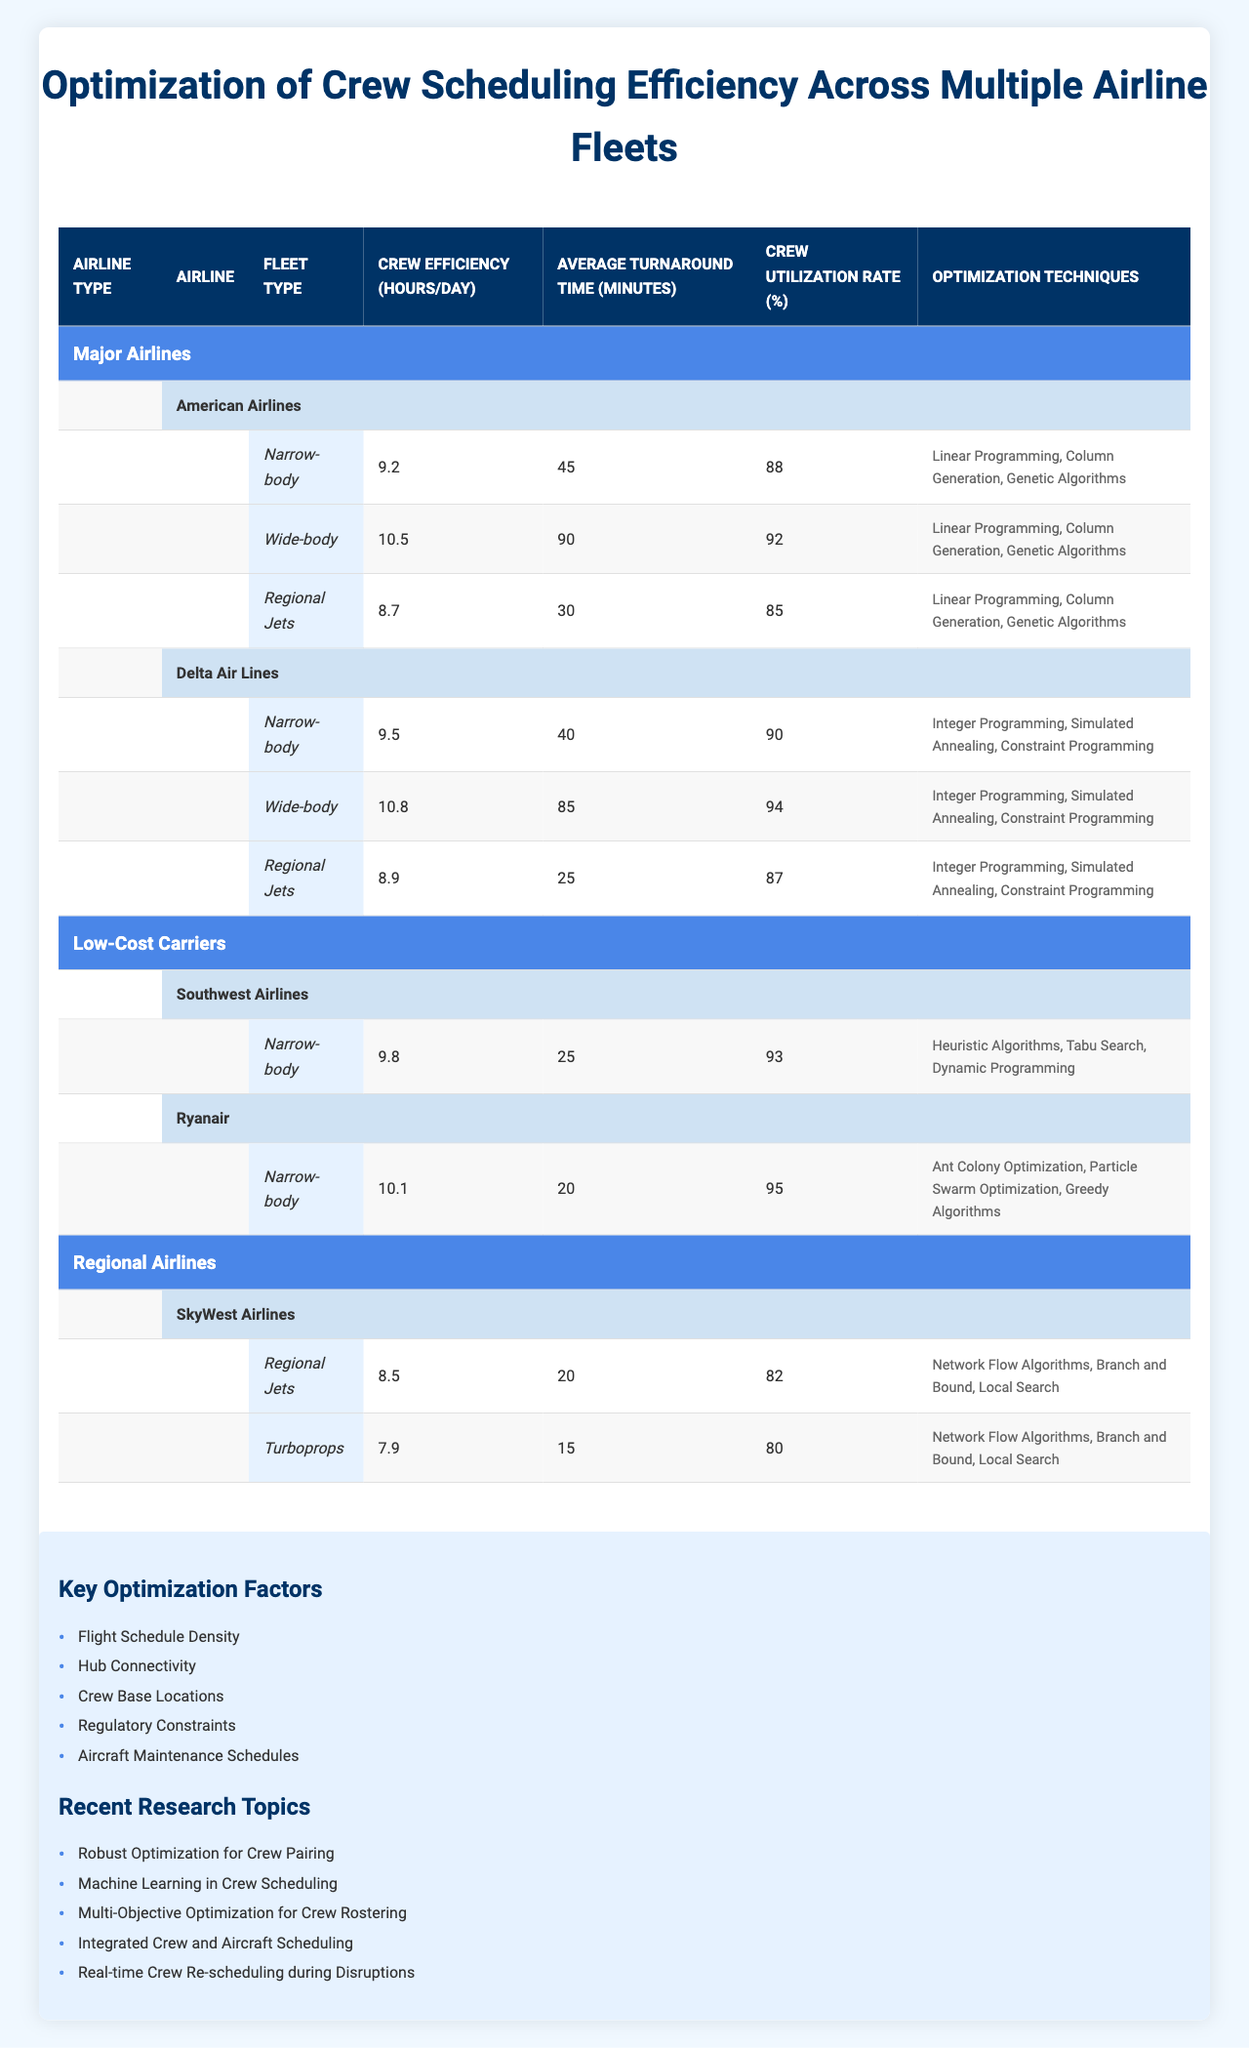What is the crew efficiency for Delta Air Lines' Wide-body fleet? According to the table, Delta Air Lines has a crew efficiency of 10.8 hours per day for their Wide-body fleet.
Answer: 10.8 Which airline has the highest crew utilization rate? Upon examining the table, Ryanair has the highest crew utilization rate at 95%.
Answer: 95% What is the average turnaround time for Southwest Airlines' Narrow-body fleet? The table shows that Southwest Airlines has an average turnaround time of 25 minutes for their Narrow-body fleet.
Answer: 25 minutes How many optimization techniques does American Airlines use? American Airlines employs three optimization techniques: Linear Programming, Column Generation, and Genetic Algorithms, as seen in the table.
Answer: 3 Is the crew efficiency for American Airlines' Regional Jets greater than that of SkyWest Airlines' Regional Jets? The table shows that American Airlines has a crew efficiency of 8.7 hours per day for Regional Jets, while SkyWest Airlines has 8.5 hours per day. Since 8.7 is greater than 8.5, the statement is true.
Answer: Yes What is the total crew efficiency for Delta Air Lines' fleet types combined? First, the crew efficiencies for Delta Air Lines are 9.5 (Narrow-body) + 10.8 (Wide-body) + 8.9 (Regional Jets) = 29.2 hours per day.
Answer: 29.2 Which optimization technique is unique to Ryanair among all listed airlines? The table indicates that Ryanair uses Ant Colony Optimization, which is not listed under any other airline's optimization techniques.
Answer: Ant Colony Optimization What is the average crew efficiency for the Narrow-body fleets of all airlines combined? First, sum the crew efficiencies: 9.2 (American Airlines) + 9.5 (Delta Air Lines) + 9.8 (Southwest Airlines) + 10.1 (Ryanair) = 38.6. Then, divide by the number of airlines (4) to get the average: 38.6 / 4 = 9.65 hours per day.
Answer: 9.65 Is it true that the average turnaround time for Regional Jets across all airlines is less than 30 minutes? The average turnaround times for Regional Jets are 30 minutes (American Airlines), 25 minutes (Delta Air Lines), and 20 minutes (SkyWest Airlines). The average is calculated as (30 + 25 + 20) / 3 = 25. Since 25 is not less than 30, the statement is false.
Answer: No What methods does Southwest Airlines deploy for optimization purposes? From the table, Southwest Airlines utilizes Heuristic Algorithms, Tabu Search, and Dynamic Programming.
Answer: Heuristic Algorithms, Tabu Search, Dynamic Programming Which airline has the lowest average turnaround time among the fleets listed? The table shows that Ryanair's Narrow-body fleet has the lowest turnaround time of 20 minutes compared to other airlines' turnaround times.
Answer: Ryanair 